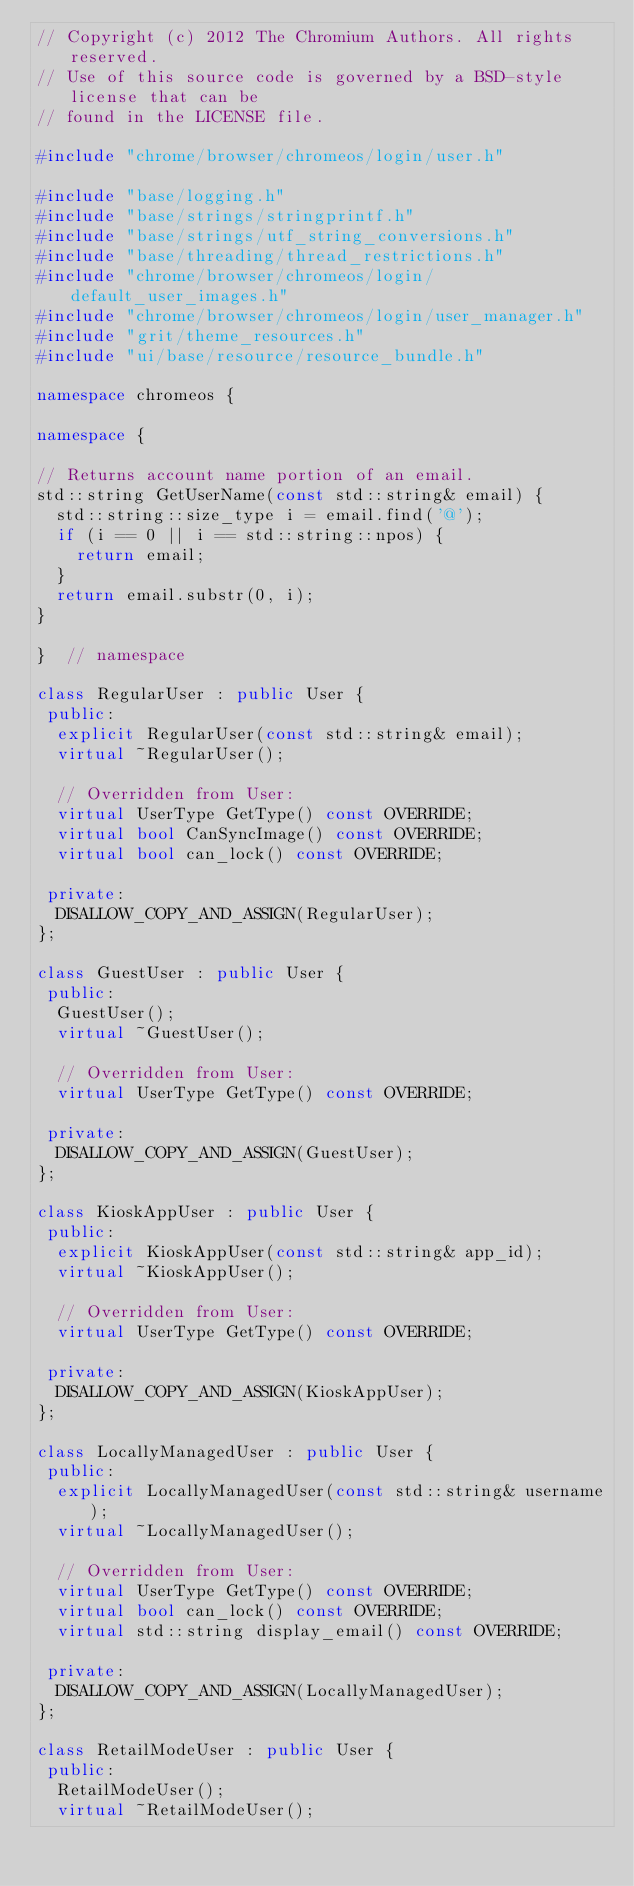Convert code to text. <code><loc_0><loc_0><loc_500><loc_500><_C++_>// Copyright (c) 2012 The Chromium Authors. All rights reserved.
// Use of this source code is governed by a BSD-style license that can be
// found in the LICENSE file.

#include "chrome/browser/chromeos/login/user.h"

#include "base/logging.h"
#include "base/strings/stringprintf.h"
#include "base/strings/utf_string_conversions.h"
#include "base/threading/thread_restrictions.h"
#include "chrome/browser/chromeos/login/default_user_images.h"
#include "chrome/browser/chromeos/login/user_manager.h"
#include "grit/theme_resources.h"
#include "ui/base/resource/resource_bundle.h"

namespace chromeos {

namespace {

// Returns account name portion of an email.
std::string GetUserName(const std::string& email) {
  std::string::size_type i = email.find('@');
  if (i == 0 || i == std::string::npos) {
    return email;
  }
  return email.substr(0, i);
}

}  // namespace

class RegularUser : public User {
 public:
  explicit RegularUser(const std::string& email);
  virtual ~RegularUser();

  // Overridden from User:
  virtual UserType GetType() const OVERRIDE;
  virtual bool CanSyncImage() const OVERRIDE;
  virtual bool can_lock() const OVERRIDE;

 private:
  DISALLOW_COPY_AND_ASSIGN(RegularUser);
};

class GuestUser : public User {
 public:
  GuestUser();
  virtual ~GuestUser();

  // Overridden from User:
  virtual UserType GetType() const OVERRIDE;

 private:
  DISALLOW_COPY_AND_ASSIGN(GuestUser);
};

class KioskAppUser : public User {
 public:
  explicit KioskAppUser(const std::string& app_id);
  virtual ~KioskAppUser();

  // Overridden from User:
  virtual UserType GetType() const OVERRIDE;

 private:
  DISALLOW_COPY_AND_ASSIGN(KioskAppUser);
};

class LocallyManagedUser : public User {
 public:
  explicit LocallyManagedUser(const std::string& username);
  virtual ~LocallyManagedUser();

  // Overridden from User:
  virtual UserType GetType() const OVERRIDE;
  virtual bool can_lock() const OVERRIDE;
  virtual std::string display_email() const OVERRIDE;

 private:
  DISALLOW_COPY_AND_ASSIGN(LocallyManagedUser);
};

class RetailModeUser : public User {
 public:
  RetailModeUser();
  virtual ~RetailModeUser();
</code> 